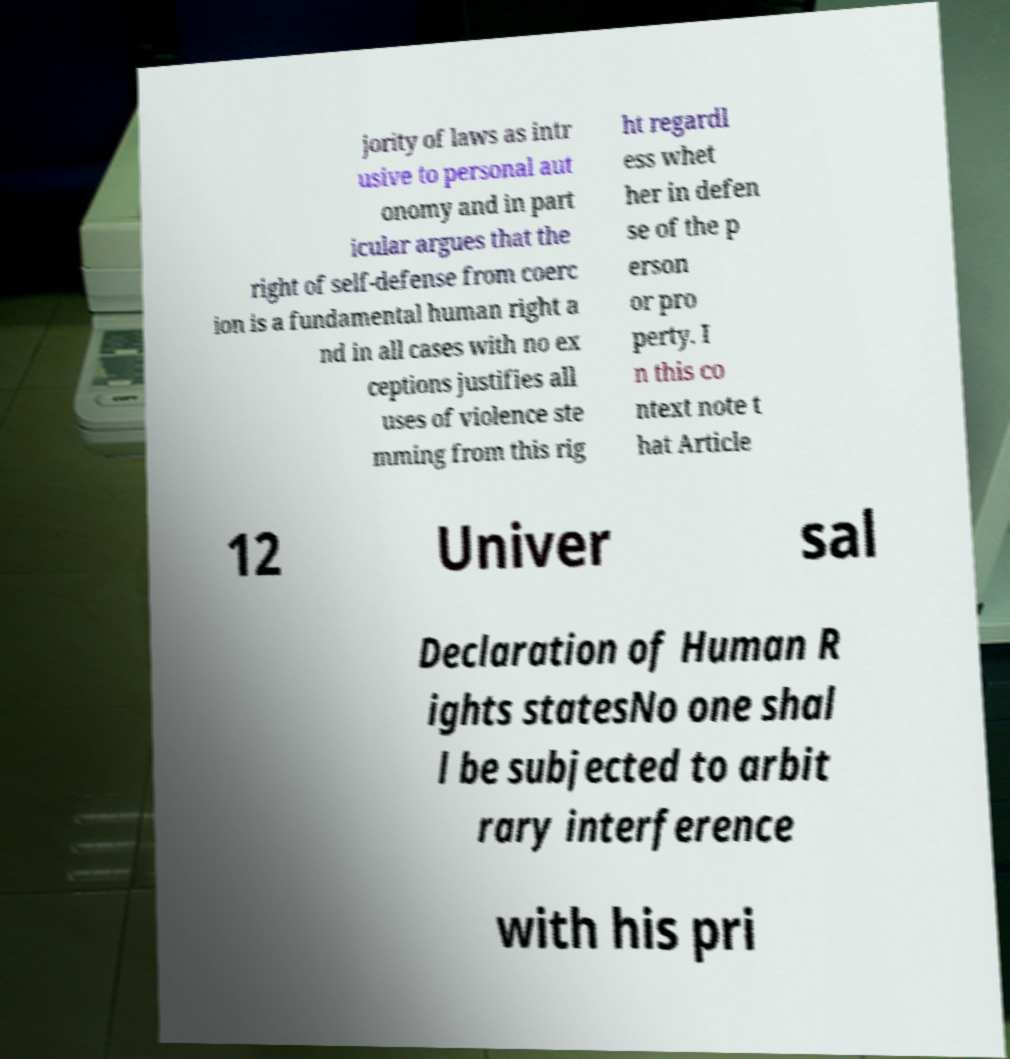Can you accurately transcribe the text from the provided image for me? jority of laws as intr usive to personal aut onomy and in part icular argues that the right of self-defense from coerc ion is a fundamental human right a nd in all cases with no ex ceptions justifies all uses of violence ste mming from this rig ht regardl ess whet her in defen se of the p erson or pro perty. I n this co ntext note t hat Article 12 Univer sal Declaration of Human R ights statesNo one shal l be subjected to arbit rary interference with his pri 